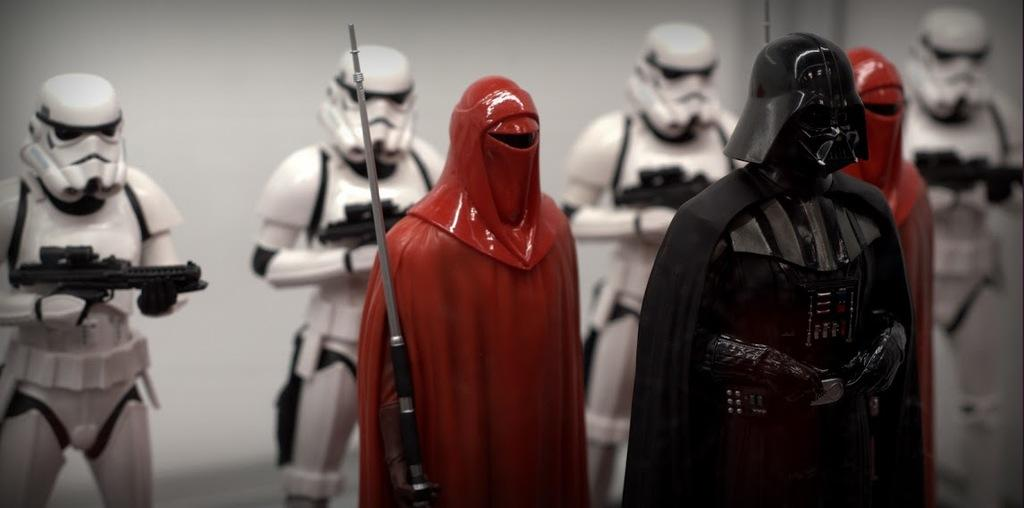What type of objects can be seen in the image? There are statues in the image. What colors are the statues? The statues are white, red, and black in color. Can you see a cart being pulled by a squirrel in the image? No, there is no cart or squirrel present in the image. 